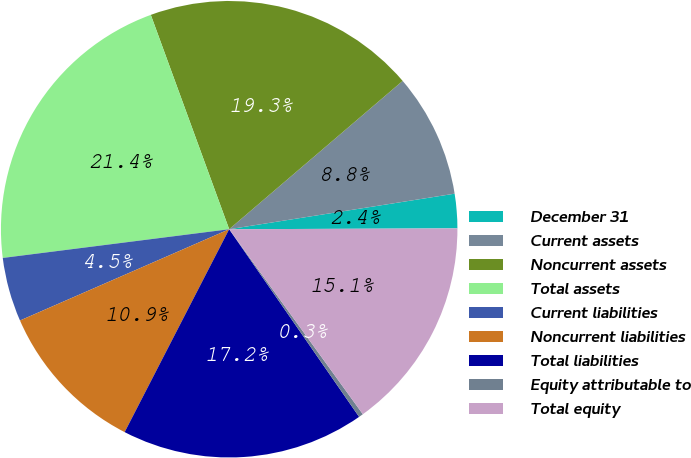Convert chart. <chart><loc_0><loc_0><loc_500><loc_500><pie_chart><fcel>December 31<fcel>Current assets<fcel>Noncurrent assets<fcel>Total assets<fcel>Current liabilities<fcel>Noncurrent liabilities<fcel>Total liabilities<fcel>Equity attributable to<fcel>Total equity<nl><fcel>2.43%<fcel>8.77%<fcel>19.32%<fcel>21.43%<fcel>4.54%<fcel>10.88%<fcel>17.21%<fcel>0.32%<fcel>15.1%<nl></chart> 